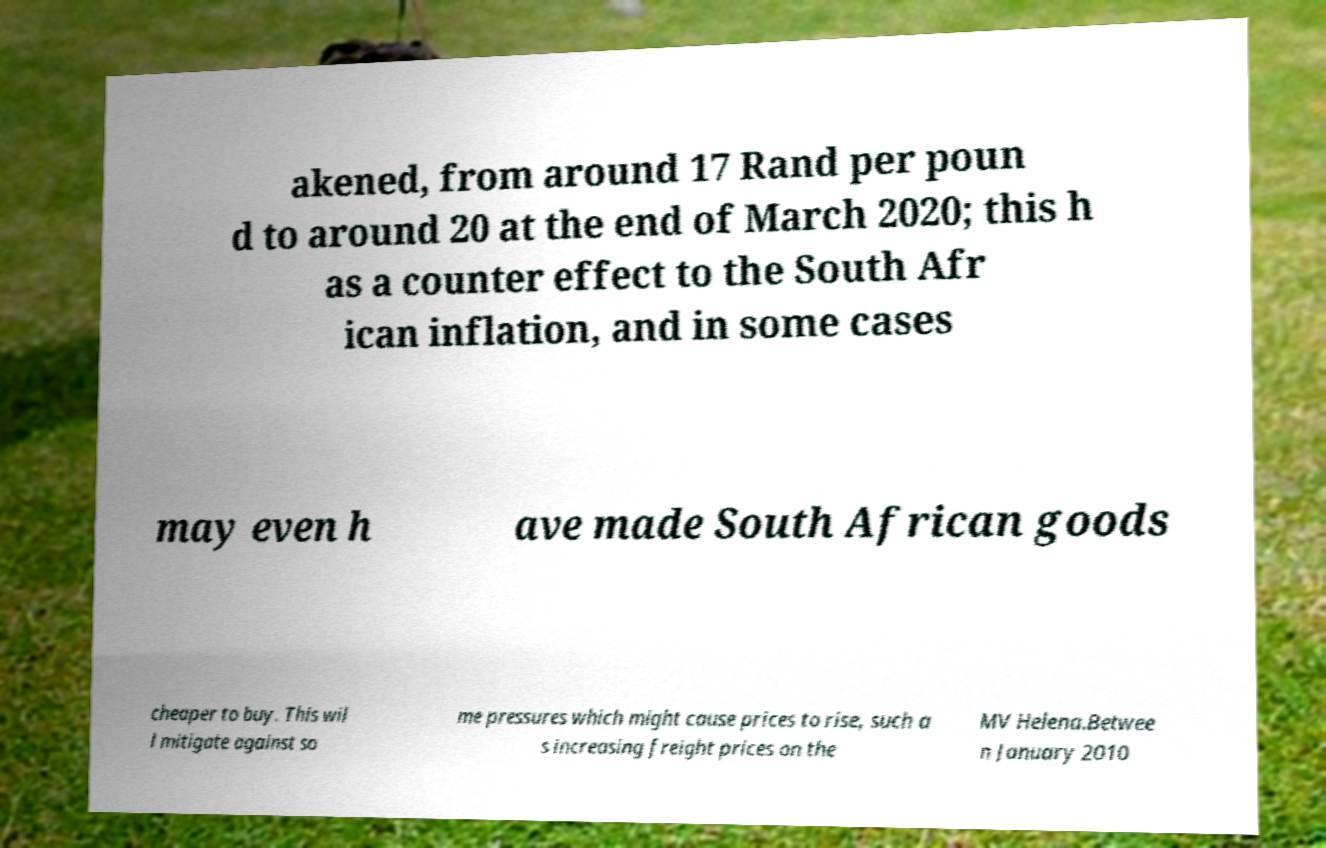What messages or text are displayed in this image? I need them in a readable, typed format. akened, from around 17 Rand per poun d to around 20 at the end of March 2020; this h as a counter effect to the South Afr ican inflation, and in some cases may even h ave made South African goods cheaper to buy. This wil l mitigate against so me pressures which might cause prices to rise, such a s increasing freight prices on the MV Helena.Betwee n January 2010 